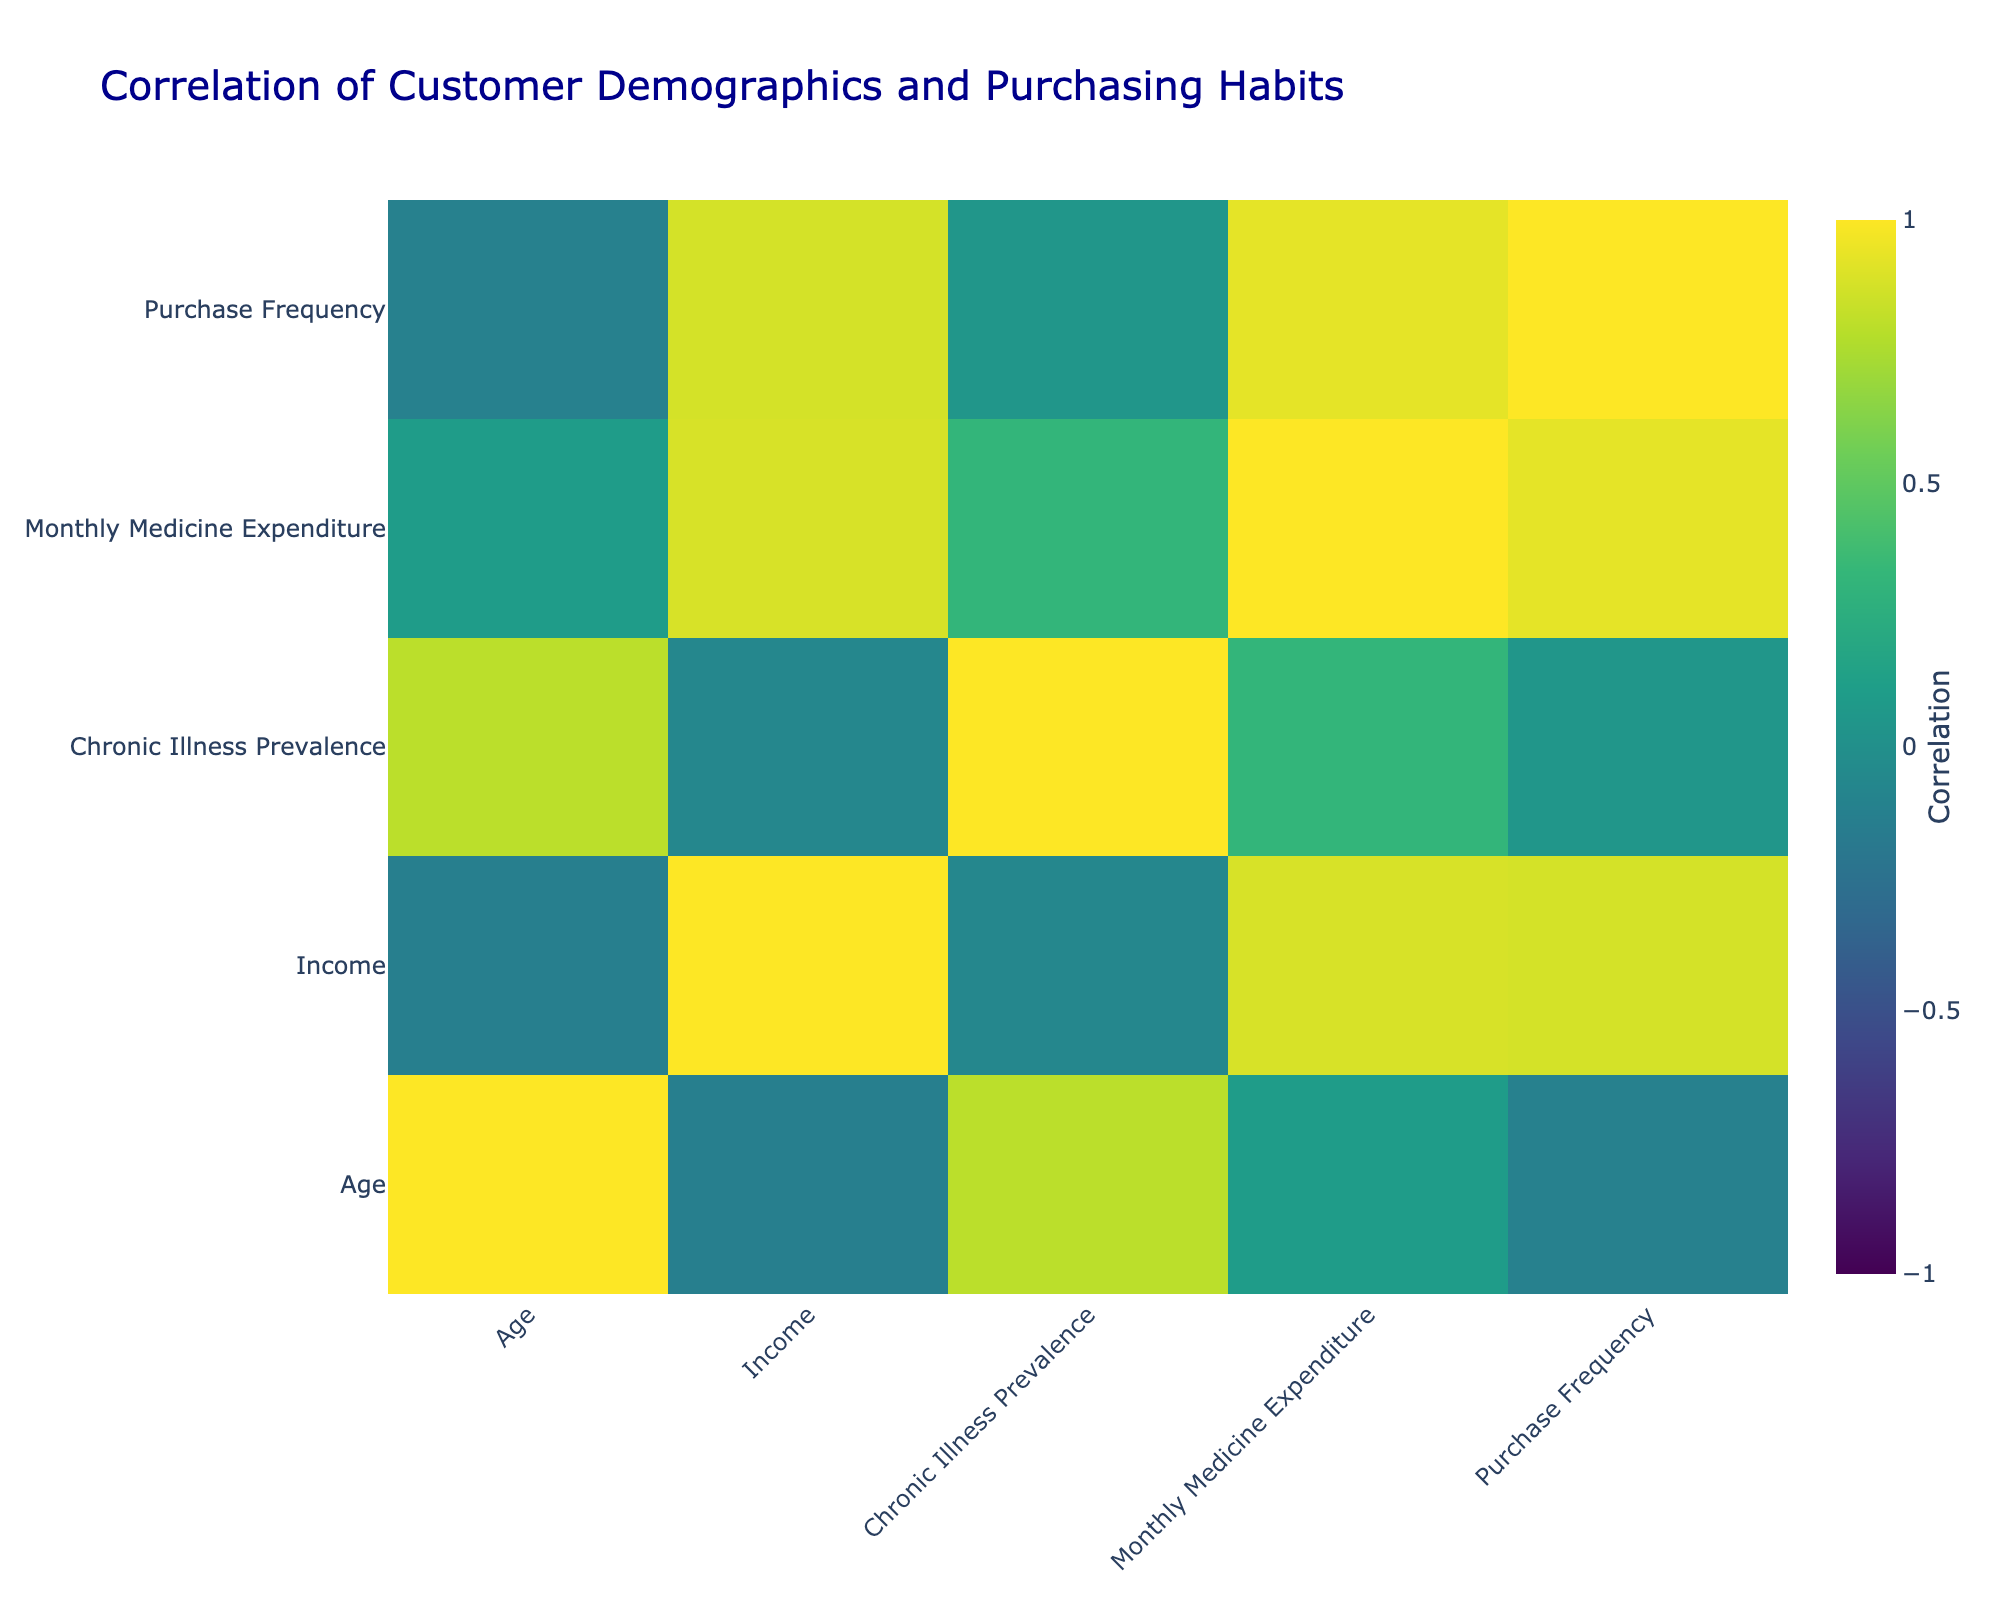What is the correlation between age and monthly medicine expenditure? The correlation coefficient between age and monthly medicine expenditure can be found directly in the correlation table. The value is 0.30, indicating a positive relationship, meaning as age increases, monthly medicine expenditure tends to increase as well.
Answer: 0.30 Is there a strong correlation between income and purchase frequency? By examining the correlation table, the correlation coefficient between income and purchase frequency is 0.23. This value indicates a weak positive correlation, suggesting that higher income is slightly associated with higher purchase frequency.
Answer: No What is the average monthly medicine expenditure for customers with a chronic illness prevalence greater than 0.5? To find the average, we first identify customers with a chronic illness prevalence greater than 0.5, which are the individuals aged 50, 55, and 40. Their monthly expenditures are 150, 200, and 120 respectively. Sum these values (150 + 200 + 120) = 470 and divide by the number of customers (3) to get an average of approximately 156.67.
Answer: 156.67 Is the preferred medicine type more likely to be generic drugs for younger customers? We can evaluate this by examining the age of customers who prefer generic drugs and how it compares to those who prefer other types. The customers who prefer generic drugs are aged 25 and 55. Both age values indicate a younger average compared to those preferring other types. Thus, it suggests that younger customers show a higher tendency to prefer generic drugs.
Answer: Yes What is the correlation between income and chronic illness prevalence? The correlation coefficient can be retrieved from the table, which is -0.15. This indicates a slight negative relationship, meaning as income increases, the prevalence of chronic illness tends to decrease slightly.
Answer: -0.15 How much more do customers with a Bachelor's degree spend on medicine monthly compared to those with a High School education? Customers with a Bachelor's degree, aged 35, have a monthly expenditure of 100. Customers with a High School education (aged 25 and 55) have expenditures of 50 and 200 respectively, giving an average of (50 + 200) / 2 = 125. Hence, the difference in spending is 100 - 125 = -25, indicating that customers with a Bachelor's degree spend 25 less on average.
Answer: -25 Is it true that older customers (over 50) tend to prefer branded drugs? Reviewing the preferences of customers over the age of 50, those customers aged 50 and 55 prefer branded drugs and the one aged 65 prefers OTC medications. While some older customers do prefer branded drugs, the data shows diversity in preferences for that age group. Thus, the statement cannot be deemed entirely true.
Answer: No What can be concluded about the purchasing habits of customers with higher education levels regarding expenditure? Analysis shows that as education level increases—from High School to Bachelor's to Master's—there is a general trend of increasing monthly medicine expenditure. This suggests that higher education correlates with increased expenditure habits on medicines.
Answer: Yes 